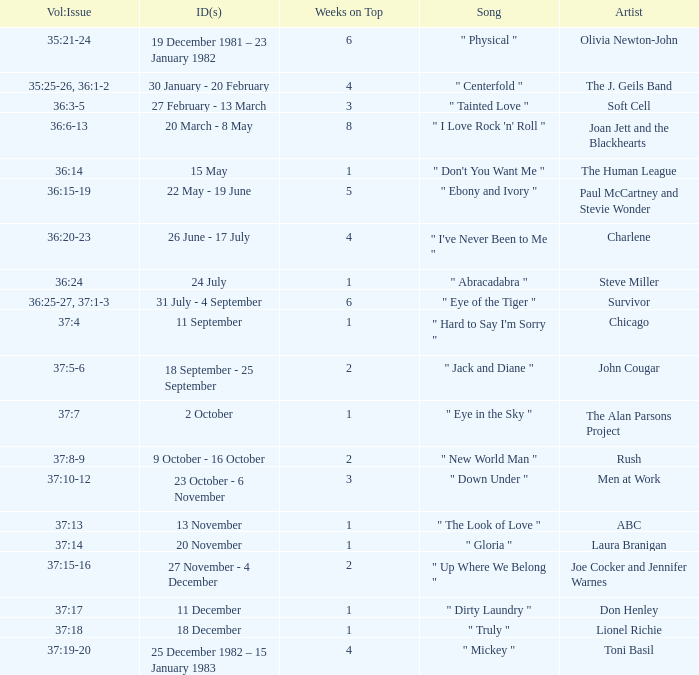Which Issue Date(s) has an Artist of men at work? 23 October - 6 November. 